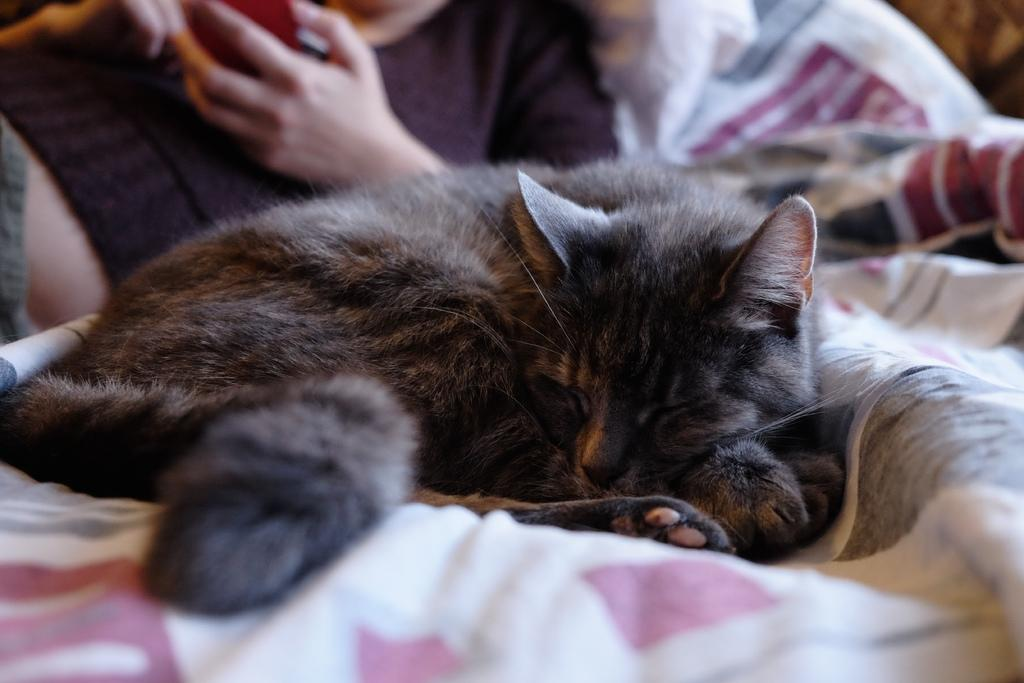What type of animal is on the bed in the image? There is a cat on the bed in the image. Can you describe the person in the image? The image only shows a person, but no specific details about their appearance or actions are provided. What type of truck can be seen in the image? There is no truck present in the image; it only features a cat on the bed and a person. What part of the brain is responsible for the cat's ability to purr in the image? The image does not provide any information about the cat's purring or the person's brain, so it is not possible to answer that question. 